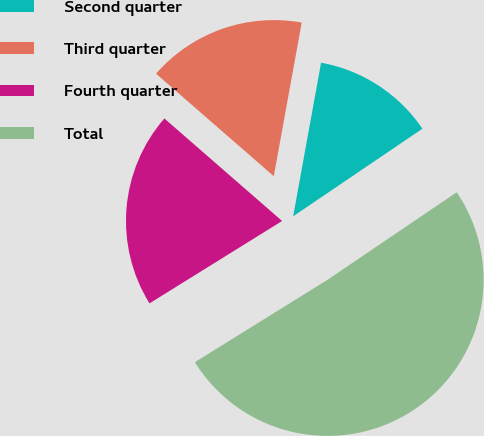<chart> <loc_0><loc_0><loc_500><loc_500><pie_chart><fcel>Second quarter<fcel>Third quarter<fcel>Fourth quarter<fcel>Total<nl><fcel>12.66%<fcel>16.46%<fcel>20.25%<fcel>50.63%<nl></chart> 